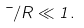Convert formula to latex. <formula><loc_0><loc_0><loc_500><loc_500>\mu / R \ll 1 .</formula> 